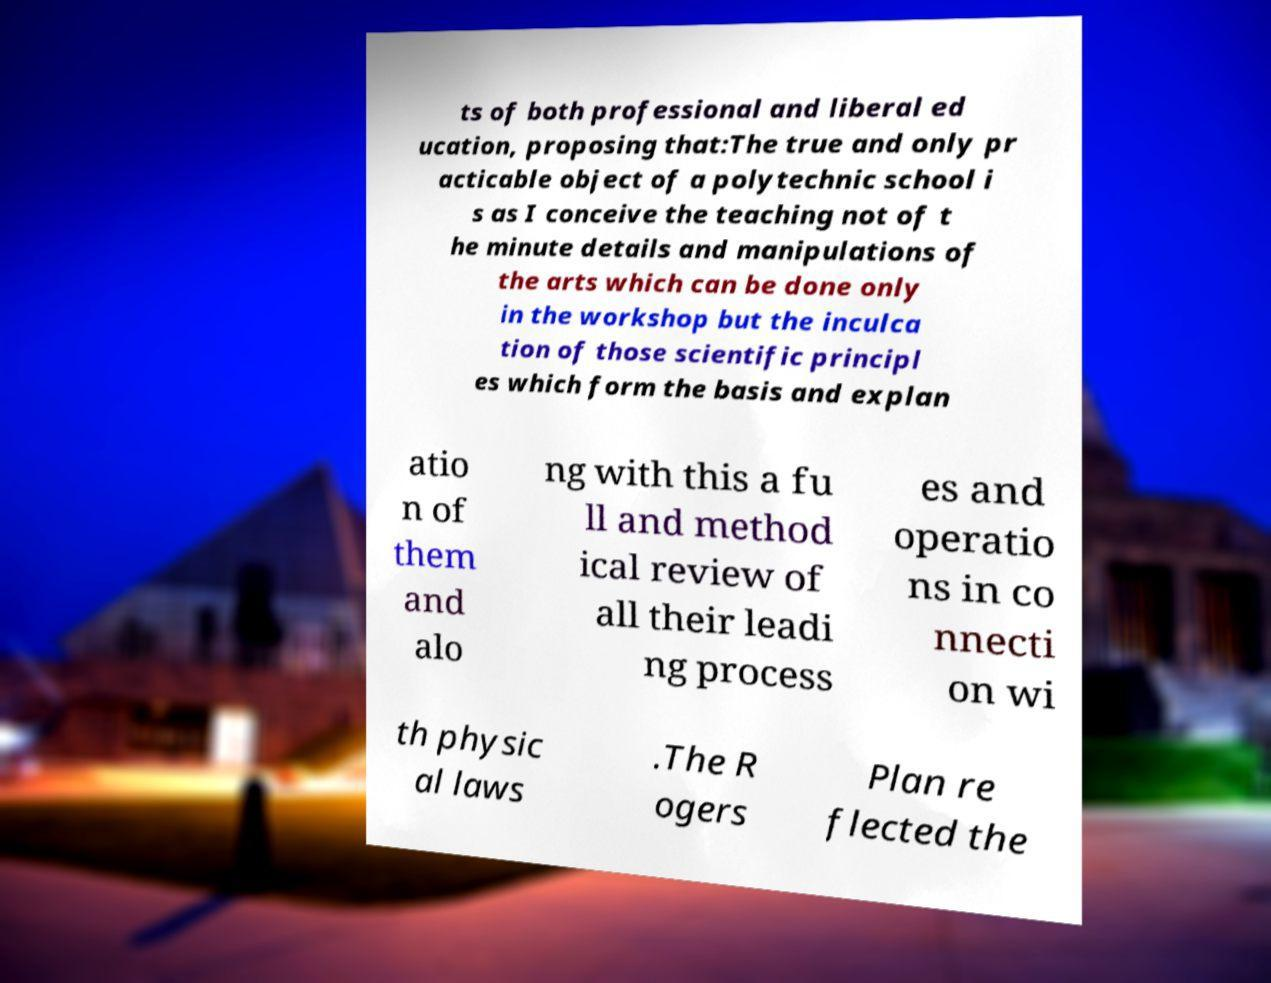I need the written content from this picture converted into text. Can you do that? ts of both professional and liberal ed ucation, proposing that:The true and only pr acticable object of a polytechnic school i s as I conceive the teaching not of t he minute details and manipulations of the arts which can be done only in the workshop but the inculca tion of those scientific principl es which form the basis and explan atio n of them and alo ng with this a fu ll and method ical review of all their leadi ng process es and operatio ns in co nnecti on wi th physic al laws .The R ogers Plan re flected the 